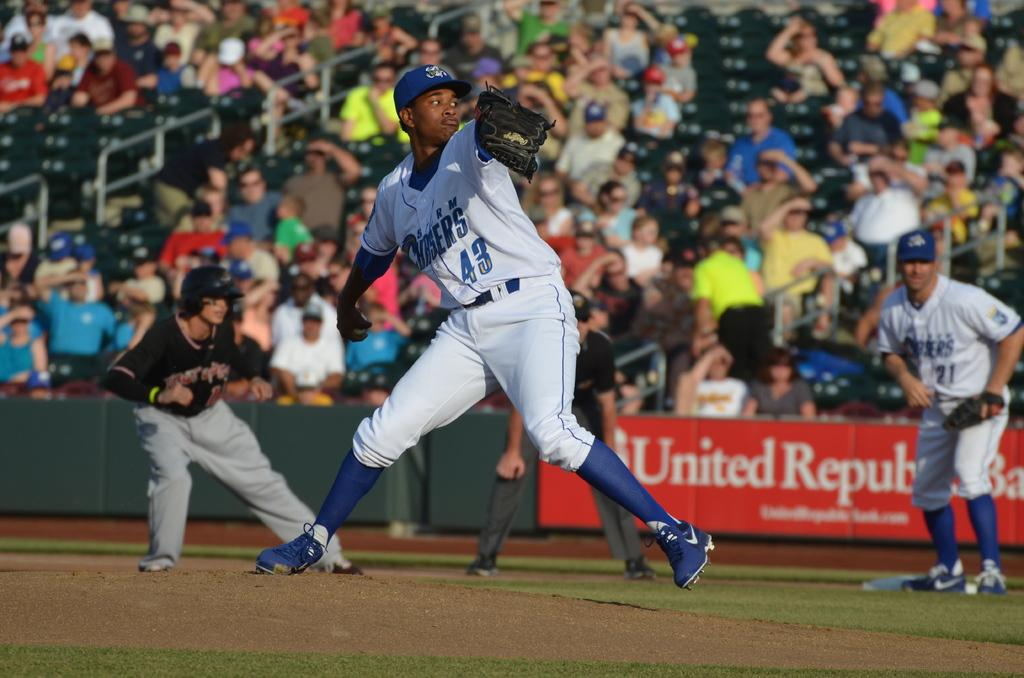<image>
Render a clear and concise summary of the photo. Number 43 of the Chargers is pitching on the mound in this game. 